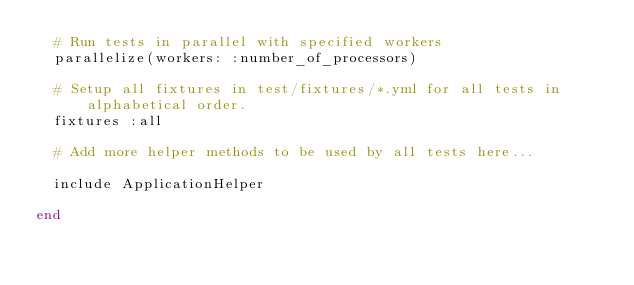<code> <loc_0><loc_0><loc_500><loc_500><_Ruby_>  # Run tests in parallel with specified workers
  parallelize(workers: :number_of_processors)

  # Setup all fixtures in test/fixtures/*.yml for all tests in alphabetical order.
  fixtures :all

  # Add more helper methods to be used by all tests here...
  
  include ApplicationHelper
  
end
</code> 